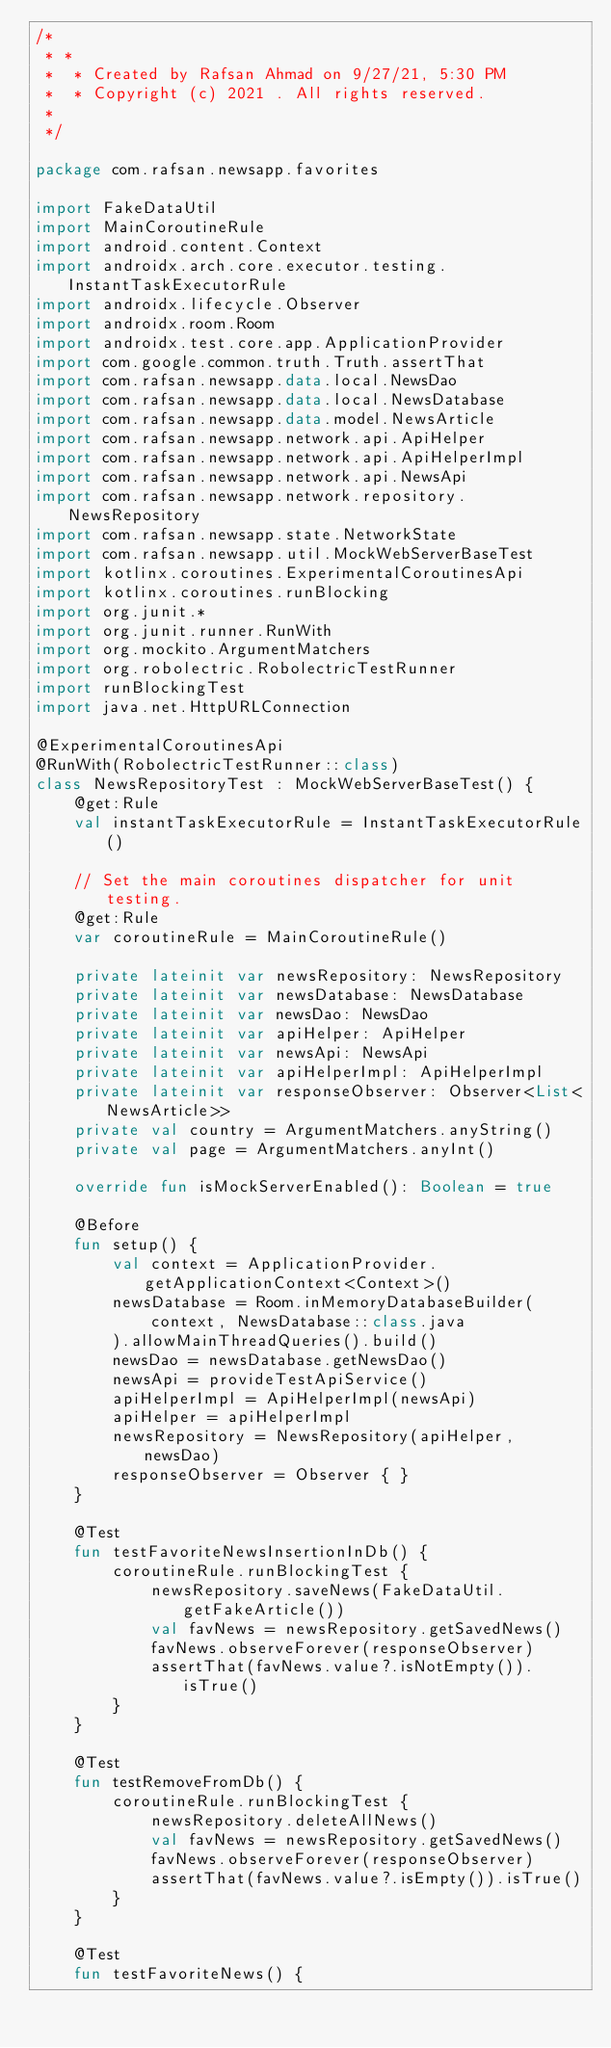Convert code to text. <code><loc_0><loc_0><loc_500><loc_500><_Kotlin_>/*
 * *
 *  * Created by Rafsan Ahmad on 9/27/21, 5:30 PM
 *  * Copyright (c) 2021 . All rights reserved.
 *
 */

package com.rafsan.newsapp.favorites

import FakeDataUtil
import MainCoroutineRule
import android.content.Context
import androidx.arch.core.executor.testing.InstantTaskExecutorRule
import androidx.lifecycle.Observer
import androidx.room.Room
import androidx.test.core.app.ApplicationProvider
import com.google.common.truth.Truth.assertThat
import com.rafsan.newsapp.data.local.NewsDao
import com.rafsan.newsapp.data.local.NewsDatabase
import com.rafsan.newsapp.data.model.NewsArticle
import com.rafsan.newsapp.network.api.ApiHelper
import com.rafsan.newsapp.network.api.ApiHelperImpl
import com.rafsan.newsapp.network.api.NewsApi
import com.rafsan.newsapp.network.repository.NewsRepository
import com.rafsan.newsapp.state.NetworkState
import com.rafsan.newsapp.util.MockWebServerBaseTest
import kotlinx.coroutines.ExperimentalCoroutinesApi
import kotlinx.coroutines.runBlocking
import org.junit.*
import org.junit.runner.RunWith
import org.mockito.ArgumentMatchers
import org.robolectric.RobolectricTestRunner
import runBlockingTest
import java.net.HttpURLConnection

@ExperimentalCoroutinesApi
@RunWith(RobolectricTestRunner::class)
class NewsRepositoryTest : MockWebServerBaseTest() {
    @get:Rule
    val instantTaskExecutorRule = InstantTaskExecutorRule()

    // Set the main coroutines dispatcher for unit testing.
    @get:Rule
    var coroutineRule = MainCoroutineRule()

    private lateinit var newsRepository: NewsRepository
    private lateinit var newsDatabase: NewsDatabase
    private lateinit var newsDao: NewsDao
    private lateinit var apiHelper: ApiHelper
    private lateinit var newsApi: NewsApi
    private lateinit var apiHelperImpl: ApiHelperImpl
    private lateinit var responseObserver: Observer<List<NewsArticle>>
    private val country = ArgumentMatchers.anyString()
    private val page = ArgumentMatchers.anyInt()

    override fun isMockServerEnabled(): Boolean = true

    @Before
    fun setup() {
        val context = ApplicationProvider.getApplicationContext<Context>()
        newsDatabase = Room.inMemoryDatabaseBuilder(
            context, NewsDatabase::class.java
        ).allowMainThreadQueries().build()
        newsDao = newsDatabase.getNewsDao()
        newsApi = provideTestApiService()
        apiHelperImpl = ApiHelperImpl(newsApi)
        apiHelper = apiHelperImpl
        newsRepository = NewsRepository(apiHelper, newsDao)
        responseObserver = Observer { }
    }

    @Test
    fun testFavoriteNewsInsertionInDb() {
        coroutineRule.runBlockingTest {
            newsRepository.saveNews(FakeDataUtil.getFakeArticle())
            val favNews = newsRepository.getSavedNews()
            favNews.observeForever(responseObserver)
            assertThat(favNews.value?.isNotEmpty()).isTrue()
        }
    }

    @Test
    fun testRemoveFromDb() {
        coroutineRule.runBlockingTest {
            newsRepository.deleteAllNews()
            val favNews = newsRepository.getSavedNews()
            favNews.observeForever(responseObserver)
            assertThat(favNews.value?.isEmpty()).isTrue()
        }
    }

    @Test
    fun testFavoriteNews() {</code> 